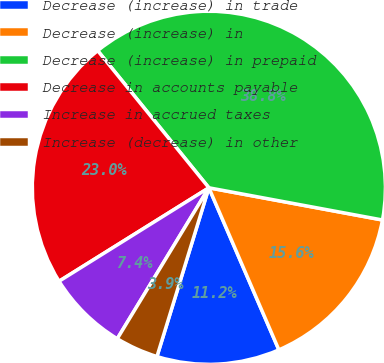Convert chart. <chart><loc_0><loc_0><loc_500><loc_500><pie_chart><fcel>Decrease (increase) in trade<fcel>Decrease (increase) in<fcel>Decrease (increase) in prepaid<fcel>Decrease in accounts payable<fcel>Increase in accrued taxes<fcel>Increase (decrease) in other<nl><fcel>11.24%<fcel>15.59%<fcel>38.76%<fcel>23.03%<fcel>7.44%<fcel>3.93%<nl></chart> 